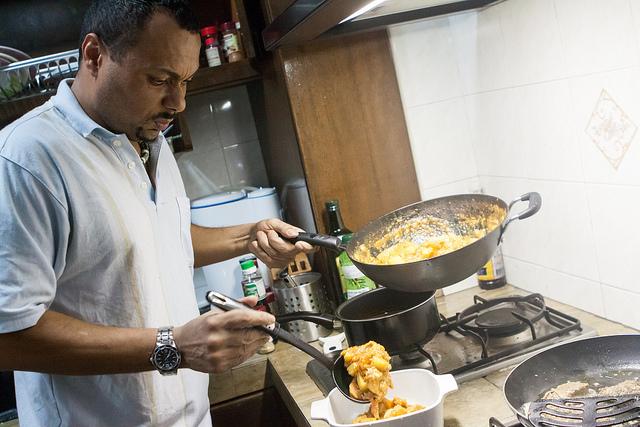What is the man cooking?
Answer briefly. Eggs. What is on the man's right arm?
Keep it brief. Watch. How does the stove cook food?
Write a very short answer. Gas. 